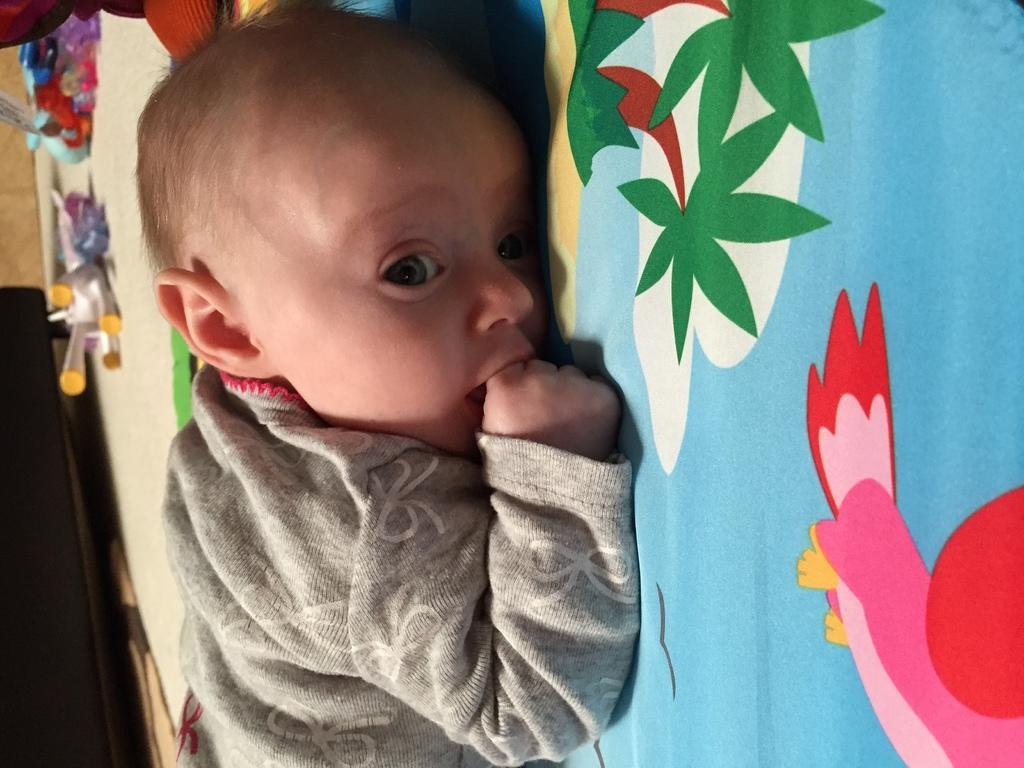Describe this image in one or two sentences. In this image I can see a baby is laying on the bed. On the bed sheet I can see some cartoon images. On the left side there are some toys. 